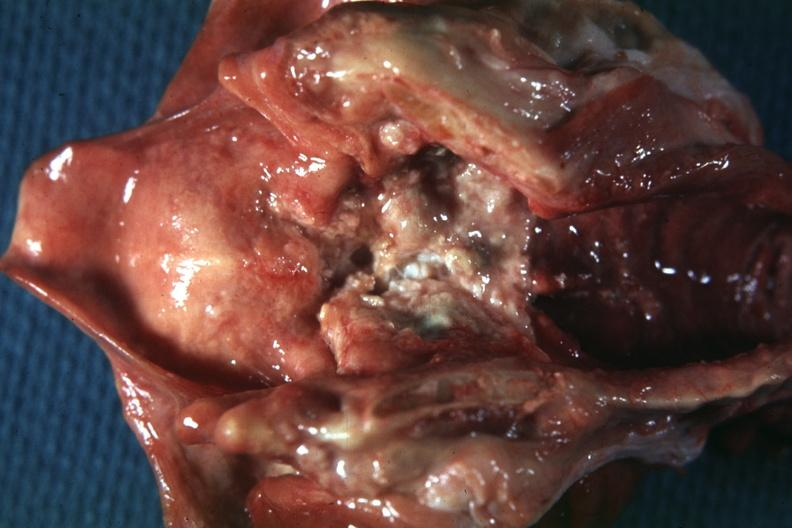what is present?
Answer the question using a single word or phrase. Larynx 